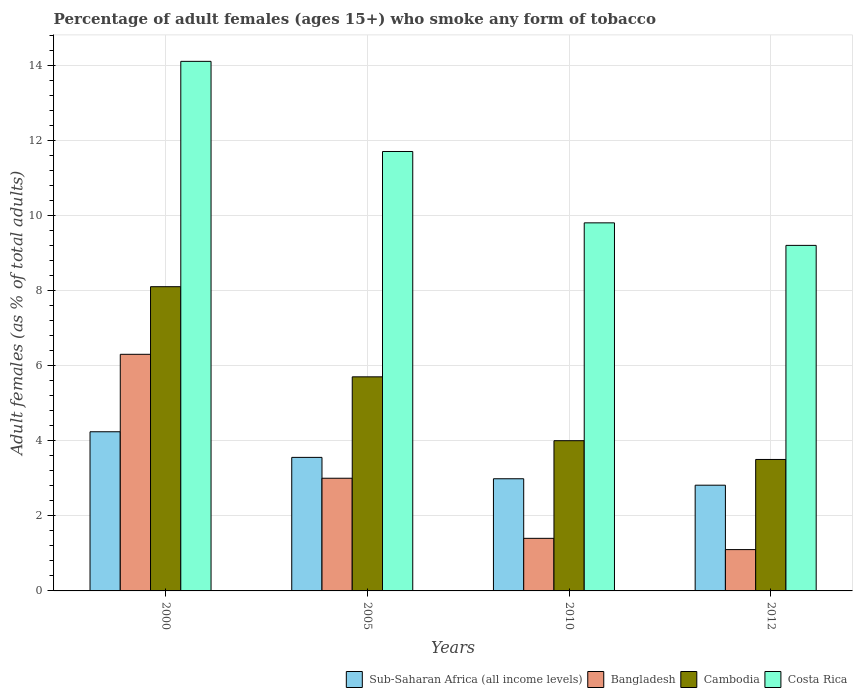Are the number of bars on each tick of the X-axis equal?
Offer a terse response. Yes. What is the label of the 3rd group of bars from the left?
Keep it short and to the point. 2010. Across all years, what is the maximum percentage of adult females who smoke in Costa Rica?
Provide a succinct answer. 14.1. Across all years, what is the minimum percentage of adult females who smoke in Sub-Saharan Africa (all income levels)?
Offer a very short reply. 2.81. In which year was the percentage of adult females who smoke in Cambodia maximum?
Make the answer very short. 2000. What is the total percentage of adult females who smoke in Cambodia in the graph?
Ensure brevity in your answer.  21.3. What is the difference between the percentage of adult females who smoke in Cambodia in 2005 and that in 2010?
Offer a terse response. 1.7. What is the difference between the percentage of adult females who smoke in Cambodia in 2000 and the percentage of adult females who smoke in Costa Rica in 2012?
Keep it short and to the point. -1.1. What is the average percentage of adult females who smoke in Bangladesh per year?
Offer a very short reply. 2.95. In the year 2010, what is the difference between the percentage of adult females who smoke in Cambodia and percentage of adult females who smoke in Costa Rica?
Provide a succinct answer. -5.8. In how many years, is the percentage of adult females who smoke in Costa Rica greater than 12.8 %?
Keep it short and to the point. 1. What is the ratio of the percentage of adult females who smoke in Bangladesh in 2000 to that in 2010?
Keep it short and to the point. 4.5. Is the difference between the percentage of adult females who smoke in Cambodia in 2000 and 2010 greater than the difference between the percentage of adult females who smoke in Costa Rica in 2000 and 2010?
Your answer should be compact. No. What is the difference between the highest and the second highest percentage of adult females who smoke in Sub-Saharan Africa (all income levels)?
Your answer should be very brief. 0.68. In how many years, is the percentage of adult females who smoke in Sub-Saharan Africa (all income levels) greater than the average percentage of adult females who smoke in Sub-Saharan Africa (all income levels) taken over all years?
Ensure brevity in your answer.  2. Is it the case that in every year, the sum of the percentage of adult females who smoke in Bangladesh and percentage of adult females who smoke in Sub-Saharan Africa (all income levels) is greater than the sum of percentage of adult females who smoke in Costa Rica and percentage of adult females who smoke in Cambodia?
Keep it short and to the point. No. What does the 4th bar from the left in 2012 represents?
Keep it short and to the point. Costa Rica. What does the 2nd bar from the right in 2012 represents?
Your answer should be compact. Cambodia. Is it the case that in every year, the sum of the percentage of adult females who smoke in Sub-Saharan Africa (all income levels) and percentage of adult females who smoke in Costa Rica is greater than the percentage of adult females who smoke in Cambodia?
Give a very brief answer. Yes. How many bars are there?
Give a very brief answer. 16. Are all the bars in the graph horizontal?
Provide a succinct answer. No. What is the difference between two consecutive major ticks on the Y-axis?
Keep it short and to the point. 2. Where does the legend appear in the graph?
Provide a succinct answer. Bottom right. How many legend labels are there?
Provide a succinct answer. 4. What is the title of the graph?
Make the answer very short. Percentage of adult females (ages 15+) who smoke any form of tobacco. What is the label or title of the Y-axis?
Your answer should be compact. Adult females (as % of total adults). What is the Adult females (as % of total adults) in Sub-Saharan Africa (all income levels) in 2000?
Your answer should be compact. 4.24. What is the Adult females (as % of total adults) of Bangladesh in 2000?
Ensure brevity in your answer.  6.3. What is the Adult females (as % of total adults) of Costa Rica in 2000?
Offer a very short reply. 14.1. What is the Adult females (as % of total adults) of Sub-Saharan Africa (all income levels) in 2005?
Your response must be concise. 3.56. What is the Adult females (as % of total adults) in Costa Rica in 2005?
Offer a terse response. 11.7. What is the Adult females (as % of total adults) in Sub-Saharan Africa (all income levels) in 2010?
Offer a terse response. 2.99. What is the Adult females (as % of total adults) of Bangladesh in 2010?
Your answer should be very brief. 1.4. What is the Adult females (as % of total adults) in Cambodia in 2010?
Provide a short and direct response. 4. What is the Adult females (as % of total adults) in Costa Rica in 2010?
Make the answer very short. 9.8. What is the Adult females (as % of total adults) of Sub-Saharan Africa (all income levels) in 2012?
Offer a very short reply. 2.81. What is the Adult females (as % of total adults) of Cambodia in 2012?
Provide a short and direct response. 3.5. What is the Adult females (as % of total adults) in Costa Rica in 2012?
Your response must be concise. 9.2. Across all years, what is the maximum Adult females (as % of total adults) in Sub-Saharan Africa (all income levels)?
Provide a succinct answer. 4.24. Across all years, what is the maximum Adult females (as % of total adults) of Bangladesh?
Offer a very short reply. 6.3. Across all years, what is the minimum Adult females (as % of total adults) in Sub-Saharan Africa (all income levels)?
Your answer should be very brief. 2.81. What is the total Adult females (as % of total adults) of Sub-Saharan Africa (all income levels) in the graph?
Your answer should be compact. 13.59. What is the total Adult females (as % of total adults) in Bangladesh in the graph?
Make the answer very short. 11.8. What is the total Adult females (as % of total adults) in Cambodia in the graph?
Give a very brief answer. 21.3. What is the total Adult females (as % of total adults) in Costa Rica in the graph?
Offer a very short reply. 44.8. What is the difference between the Adult females (as % of total adults) in Sub-Saharan Africa (all income levels) in 2000 and that in 2005?
Offer a terse response. 0.68. What is the difference between the Adult females (as % of total adults) in Bangladesh in 2000 and that in 2005?
Ensure brevity in your answer.  3.3. What is the difference between the Adult females (as % of total adults) in Cambodia in 2000 and that in 2005?
Ensure brevity in your answer.  2.4. What is the difference between the Adult females (as % of total adults) of Sub-Saharan Africa (all income levels) in 2000 and that in 2010?
Your response must be concise. 1.25. What is the difference between the Adult females (as % of total adults) of Bangladesh in 2000 and that in 2010?
Offer a terse response. 4.9. What is the difference between the Adult females (as % of total adults) of Sub-Saharan Africa (all income levels) in 2000 and that in 2012?
Offer a terse response. 1.42. What is the difference between the Adult females (as % of total adults) in Cambodia in 2000 and that in 2012?
Provide a succinct answer. 4.6. What is the difference between the Adult females (as % of total adults) of Costa Rica in 2000 and that in 2012?
Your answer should be compact. 4.9. What is the difference between the Adult females (as % of total adults) of Sub-Saharan Africa (all income levels) in 2005 and that in 2010?
Provide a short and direct response. 0.57. What is the difference between the Adult females (as % of total adults) of Bangladesh in 2005 and that in 2010?
Offer a very short reply. 1.6. What is the difference between the Adult females (as % of total adults) of Costa Rica in 2005 and that in 2010?
Keep it short and to the point. 1.9. What is the difference between the Adult females (as % of total adults) of Sub-Saharan Africa (all income levels) in 2005 and that in 2012?
Keep it short and to the point. 0.74. What is the difference between the Adult females (as % of total adults) of Costa Rica in 2005 and that in 2012?
Provide a short and direct response. 2.5. What is the difference between the Adult females (as % of total adults) in Sub-Saharan Africa (all income levels) in 2010 and that in 2012?
Offer a very short reply. 0.17. What is the difference between the Adult females (as % of total adults) in Bangladesh in 2010 and that in 2012?
Your answer should be very brief. 0.3. What is the difference between the Adult females (as % of total adults) of Costa Rica in 2010 and that in 2012?
Ensure brevity in your answer.  0.6. What is the difference between the Adult females (as % of total adults) of Sub-Saharan Africa (all income levels) in 2000 and the Adult females (as % of total adults) of Bangladesh in 2005?
Provide a short and direct response. 1.24. What is the difference between the Adult females (as % of total adults) in Sub-Saharan Africa (all income levels) in 2000 and the Adult females (as % of total adults) in Cambodia in 2005?
Your response must be concise. -1.46. What is the difference between the Adult females (as % of total adults) of Sub-Saharan Africa (all income levels) in 2000 and the Adult females (as % of total adults) of Costa Rica in 2005?
Ensure brevity in your answer.  -7.46. What is the difference between the Adult females (as % of total adults) in Cambodia in 2000 and the Adult females (as % of total adults) in Costa Rica in 2005?
Make the answer very short. -3.6. What is the difference between the Adult females (as % of total adults) of Sub-Saharan Africa (all income levels) in 2000 and the Adult females (as % of total adults) of Bangladesh in 2010?
Give a very brief answer. 2.84. What is the difference between the Adult females (as % of total adults) in Sub-Saharan Africa (all income levels) in 2000 and the Adult females (as % of total adults) in Cambodia in 2010?
Your answer should be very brief. 0.24. What is the difference between the Adult females (as % of total adults) in Sub-Saharan Africa (all income levels) in 2000 and the Adult females (as % of total adults) in Costa Rica in 2010?
Offer a very short reply. -5.56. What is the difference between the Adult females (as % of total adults) in Bangladesh in 2000 and the Adult females (as % of total adults) in Cambodia in 2010?
Make the answer very short. 2.3. What is the difference between the Adult females (as % of total adults) of Sub-Saharan Africa (all income levels) in 2000 and the Adult females (as % of total adults) of Bangladesh in 2012?
Keep it short and to the point. 3.14. What is the difference between the Adult females (as % of total adults) of Sub-Saharan Africa (all income levels) in 2000 and the Adult females (as % of total adults) of Cambodia in 2012?
Provide a short and direct response. 0.74. What is the difference between the Adult females (as % of total adults) of Sub-Saharan Africa (all income levels) in 2000 and the Adult females (as % of total adults) of Costa Rica in 2012?
Provide a succinct answer. -4.96. What is the difference between the Adult females (as % of total adults) of Cambodia in 2000 and the Adult females (as % of total adults) of Costa Rica in 2012?
Your answer should be compact. -1.1. What is the difference between the Adult females (as % of total adults) in Sub-Saharan Africa (all income levels) in 2005 and the Adult females (as % of total adults) in Bangladesh in 2010?
Your response must be concise. 2.16. What is the difference between the Adult females (as % of total adults) of Sub-Saharan Africa (all income levels) in 2005 and the Adult females (as % of total adults) of Cambodia in 2010?
Make the answer very short. -0.44. What is the difference between the Adult females (as % of total adults) of Sub-Saharan Africa (all income levels) in 2005 and the Adult females (as % of total adults) of Costa Rica in 2010?
Your response must be concise. -6.24. What is the difference between the Adult females (as % of total adults) of Bangladesh in 2005 and the Adult females (as % of total adults) of Cambodia in 2010?
Offer a very short reply. -1. What is the difference between the Adult females (as % of total adults) in Bangladesh in 2005 and the Adult females (as % of total adults) in Costa Rica in 2010?
Your answer should be very brief. -6.8. What is the difference between the Adult females (as % of total adults) of Sub-Saharan Africa (all income levels) in 2005 and the Adult females (as % of total adults) of Bangladesh in 2012?
Provide a short and direct response. 2.46. What is the difference between the Adult females (as % of total adults) in Sub-Saharan Africa (all income levels) in 2005 and the Adult females (as % of total adults) in Cambodia in 2012?
Offer a terse response. 0.06. What is the difference between the Adult females (as % of total adults) of Sub-Saharan Africa (all income levels) in 2005 and the Adult females (as % of total adults) of Costa Rica in 2012?
Offer a terse response. -5.64. What is the difference between the Adult females (as % of total adults) of Bangladesh in 2005 and the Adult females (as % of total adults) of Costa Rica in 2012?
Your response must be concise. -6.2. What is the difference between the Adult females (as % of total adults) in Cambodia in 2005 and the Adult females (as % of total adults) in Costa Rica in 2012?
Offer a very short reply. -3.5. What is the difference between the Adult females (as % of total adults) of Sub-Saharan Africa (all income levels) in 2010 and the Adult females (as % of total adults) of Bangladesh in 2012?
Make the answer very short. 1.89. What is the difference between the Adult females (as % of total adults) of Sub-Saharan Africa (all income levels) in 2010 and the Adult females (as % of total adults) of Cambodia in 2012?
Your answer should be very brief. -0.51. What is the difference between the Adult females (as % of total adults) in Sub-Saharan Africa (all income levels) in 2010 and the Adult females (as % of total adults) in Costa Rica in 2012?
Offer a very short reply. -6.21. What is the difference between the Adult females (as % of total adults) of Bangladesh in 2010 and the Adult females (as % of total adults) of Costa Rica in 2012?
Provide a succinct answer. -7.8. What is the difference between the Adult females (as % of total adults) in Cambodia in 2010 and the Adult females (as % of total adults) in Costa Rica in 2012?
Ensure brevity in your answer.  -5.2. What is the average Adult females (as % of total adults) in Sub-Saharan Africa (all income levels) per year?
Provide a succinct answer. 3.4. What is the average Adult females (as % of total adults) in Bangladesh per year?
Provide a short and direct response. 2.95. What is the average Adult females (as % of total adults) in Cambodia per year?
Your answer should be compact. 5.33. What is the average Adult females (as % of total adults) in Costa Rica per year?
Ensure brevity in your answer.  11.2. In the year 2000, what is the difference between the Adult females (as % of total adults) in Sub-Saharan Africa (all income levels) and Adult females (as % of total adults) in Bangladesh?
Provide a short and direct response. -2.06. In the year 2000, what is the difference between the Adult females (as % of total adults) of Sub-Saharan Africa (all income levels) and Adult females (as % of total adults) of Cambodia?
Provide a short and direct response. -3.86. In the year 2000, what is the difference between the Adult females (as % of total adults) in Sub-Saharan Africa (all income levels) and Adult females (as % of total adults) in Costa Rica?
Your response must be concise. -9.86. In the year 2000, what is the difference between the Adult females (as % of total adults) of Bangladesh and Adult females (as % of total adults) of Cambodia?
Offer a terse response. -1.8. In the year 2000, what is the difference between the Adult females (as % of total adults) in Cambodia and Adult females (as % of total adults) in Costa Rica?
Your answer should be compact. -6. In the year 2005, what is the difference between the Adult females (as % of total adults) in Sub-Saharan Africa (all income levels) and Adult females (as % of total adults) in Bangladesh?
Provide a succinct answer. 0.56. In the year 2005, what is the difference between the Adult females (as % of total adults) in Sub-Saharan Africa (all income levels) and Adult females (as % of total adults) in Cambodia?
Keep it short and to the point. -2.14. In the year 2005, what is the difference between the Adult females (as % of total adults) of Sub-Saharan Africa (all income levels) and Adult females (as % of total adults) of Costa Rica?
Offer a very short reply. -8.14. In the year 2010, what is the difference between the Adult females (as % of total adults) of Sub-Saharan Africa (all income levels) and Adult females (as % of total adults) of Bangladesh?
Your answer should be very brief. 1.59. In the year 2010, what is the difference between the Adult females (as % of total adults) of Sub-Saharan Africa (all income levels) and Adult females (as % of total adults) of Cambodia?
Give a very brief answer. -1.01. In the year 2010, what is the difference between the Adult females (as % of total adults) in Sub-Saharan Africa (all income levels) and Adult females (as % of total adults) in Costa Rica?
Provide a short and direct response. -6.81. In the year 2010, what is the difference between the Adult females (as % of total adults) of Bangladesh and Adult females (as % of total adults) of Cambodia?
Offer a terse response. -2.6. In the year 2010, what is the difference between the Adult females (as % of total adults) in Bangladesh and Adult females (as % of total adults) in Costa Rica?
Provide a short and direct response. -8.4. In the year 2010, what is the difference between the Adult females (as % of total adults) of Cambodia and Adult females (as % of total adults) of Costa Rica?
Offer a very short reply. -5.8. In the year 2012, what is the difference between the Adult females (as % of total adults) in Sub-Saharan Africa (all income levels) and Adult females (as % of total adults) in Bangladesh?
Keep it short and to the point. 1.71. In the year 2012, what is the difference between the Adult females (as % of total adults) of Sub-Saharan Africa (all income levels) and Adult females (as % of total adults) of Cambodia?
Your answer should be compact. -0.69. In the year 2012, what is the difference between the Adult females (as % of total adults) of Sub-Saharan Africa (all income levels) and Adult females (as % of total adults) of Costa Rica?
Your response must be concise. -6.39. In the year 2012, what is the difference between the Adult females (as % of total adults) of Bangladesh and Adult females (as % of total adults) of Costa Rica?
Your response must be concise. -8.1. In the year 2012, what is the difference between the Adult females (as % of total adults) of Cambodia and Adult females (as % of total adults) of Costa Rica?
Your answer should be very brief. -5.7. What is the ratio of the Adult females (as % of total adults) in Sub-Saharan Africa (all income levels) in 2000 to that in 2005?
Your answer should be very brief. 1.19. What is the ratio of the Adult females (as % of total adults) in Bangladesh in 2000 to that in 2005?
Provide a succinct answer. 2.1. What is the ratio of the Adult females (as % of total adults) in Cambodia in 2000 to that in 2005?
Give a very brief answer. 1.42. What is the ratio of the Adult females (as % of total adults) in Costa Rica in 2000 to that in 2005?
Offer a terse response. 1.21. What is the ratio of the Adult females (as % of total adults) of Sub-Saharan Africa (all income levels) in 2000 to that in 2010?
Your answer should be very brief. 1.42. What is the ratio of the Adult females (as % of total adults) in Cambodia in 2000 to that in 2010?
Ensure brevity in your answer.  2.02. What is the ratio of the Adult females (as % of total adults) in Costa Rica in 2000 to that in 2010?
Ensure brevity in your answer.  1.44. What is the ratio of the Adult females (as % of total adults) in Sub-Saharan Africa (all income levels) in 2000 to that in 2012?
Provide a succinct answer. 1.51. What is the ratio of the Adult females (as % of total adults) of Bangladesh in 2000 to that in 2012?
Ensure brevity in your answer.  5.73. What is the ratio of the Adult females (as % of total adults) of Cambodia in 2000 to that in 2012?
Keep it short and to the point. 2.31. What is the ratio of the Adult females (as % of total adults) in Costa Rica in 2000 to that in 2012?
Keep it short and to the point. 1.53. What is the ratio of the Adult females (as % of total adults) of Sub-Saharan Africa (all income levels) in 2005 to that in 2010?
Your answer should be very brief. 1.19. What is the ratio of the Adult females (as % of total adults) in Bangladesh in 2005 to that in 2010?
Offer a terse response. 2.14. What is the ratio of the Adult females (as % of total adults) in Cambodia in 2005 to that in 2010?
Offer a very short reply. 1.43. What is the ratio of the Adult females (as % of total adults) in Costa Rica in 2005 to that in 2010?
Offer a very short reply. 1.19. What is the ratio of the Adult females (as % of total adults) of Sub-Saharan Africa (all income levels) in 2005 to that in 2012?
Provide a short and direct response. 1.26. What is the ratio of the Adult females (as % of total adults) in Bangladesh in 2005 to that in 2012?
Ensure brevity in your answer.  2.73. What is the ratio of the Adult females (as % of total adults) of Cambodia in 2005 to that in 2012?
Keep it short and to the point. 1.63. What is the ratio of the Adult females (as % of total adults) in Costa Rica in 2005 to that in 2012?
Your answer should be very brief. 1.27. What is the ratio of the Adult females (as % of total adults) in Sub-Saharan Africa (all income levels) in 2010 to that in 2012?
Provide a short and direct response. 1.06. What is the ratio of the Adult females (as % of total adults) of Bangladesh in 2010 to that in 2012?
Ensure brevity in your answer.  1.27. What is the ratio of the Adult females (as % of total adults) in Cambodia in 2010 to that in 2012?
Keep it short and to the point. 1.14. What is the ratio of the Adult females (as % of total adults) of Costa Rica in 2010 to that in 2012?
Offer a terse response. 1.07. What is the difference between the highest and the second highest Adult females (as % of total adults) of Sub-Saharan Africa (all income levels)?
Make the answer very short. 0.68. What is the difference between the highest and the lowest Adult females (as % of total adults) in Sub-Saharan Africa (all income levels)?
Ensure brevity in your answer.  1.42. What is the difference between the highest and the lowest Adult females (as % of total adults) in Cambodia?
Keep it short and to the point. 4.6. What is the difference between the highest and the lowest Adult females (as % of total adults) in Costa Rica?
Make the answer very short. 4.9. 